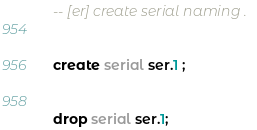<code> <loc_0><loc_0><loc_500><loc_500><_SQL_>-- [er] create serial naming .


create serial ser.1 ;


drop serial ser.1;</code> 